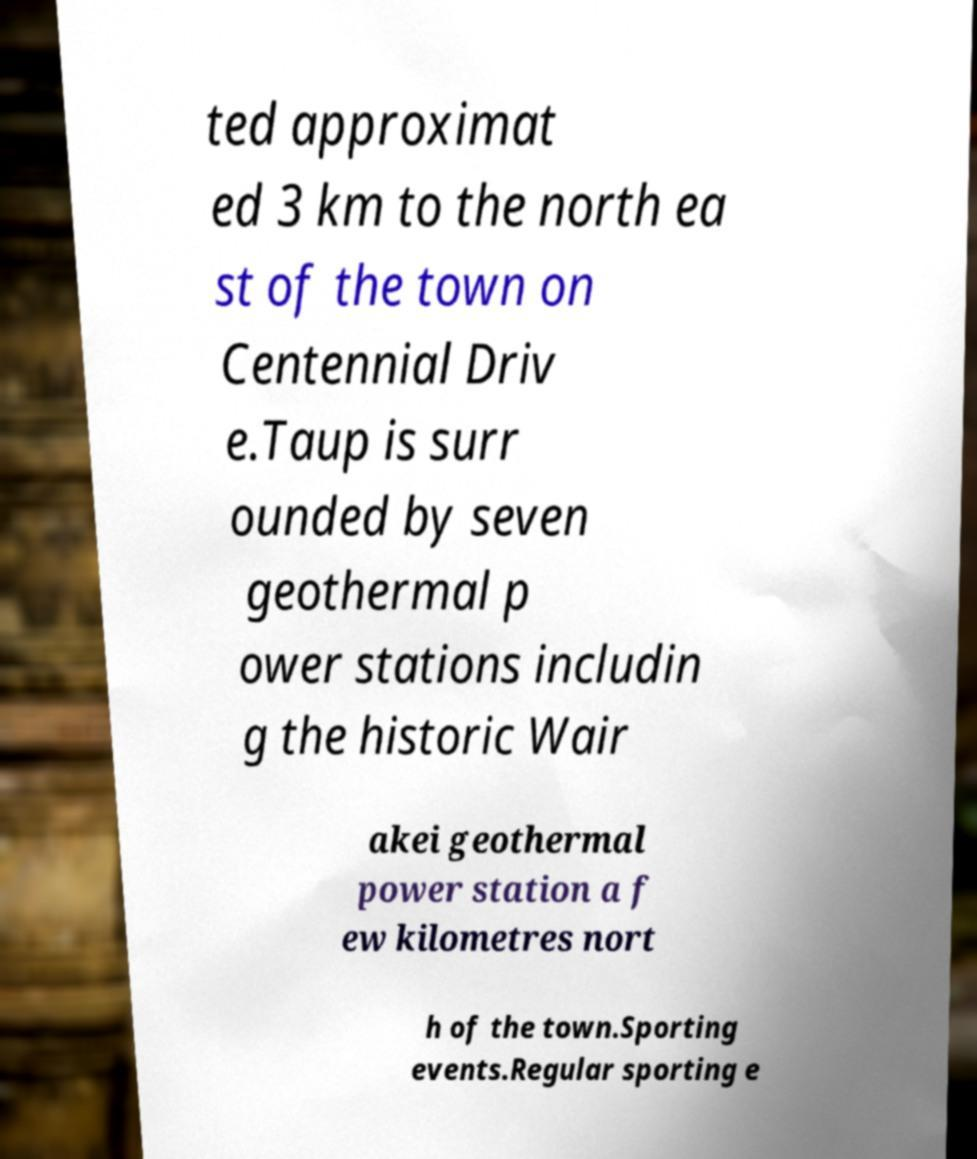Please read and relay the text visible in this image. What does it say? ted approximat ed 3 km to the north ea st of the town on Centennial Driv e.Taup is surr ounded by seven geothermal p ower stations includin g the historic Wair akei geothermal power station a f ew kilometres nort h of the town.Sporting events.Regular sporting e 